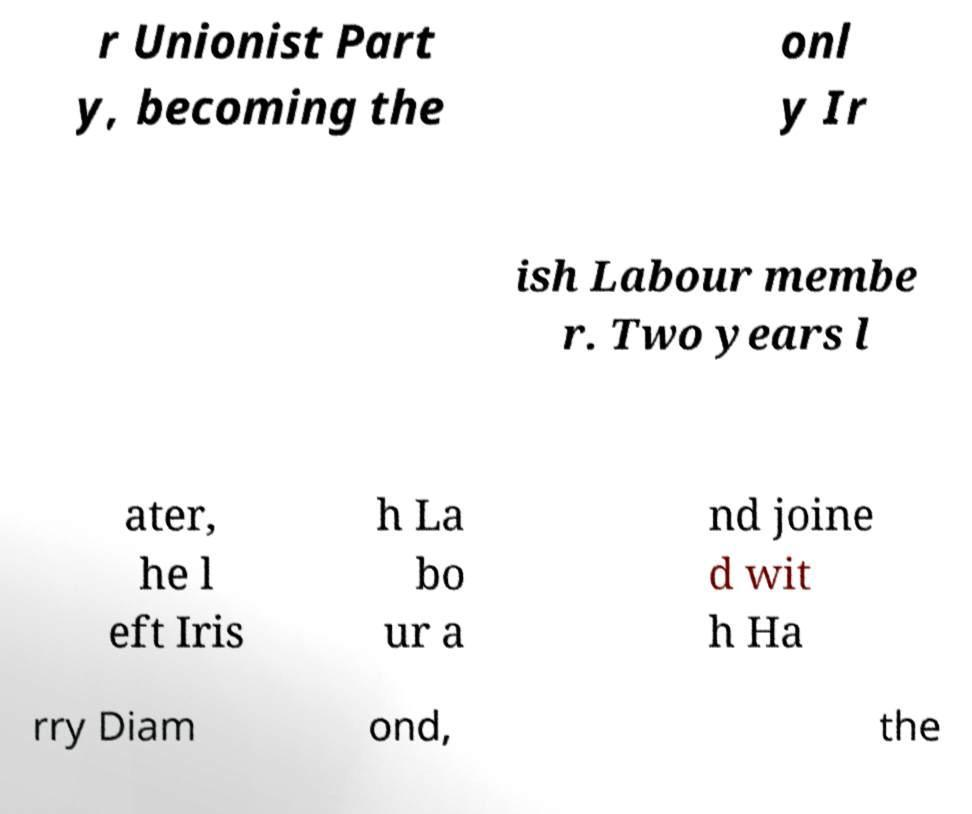I need the written content from this picture converted into text. Can you do that? r Unionist Part y, becoming the onl y Ir ish Labour membe r. Two years l ater, he l eft Iris h La bo ur a nd joine d wit h Ha rry Diam ond, the 